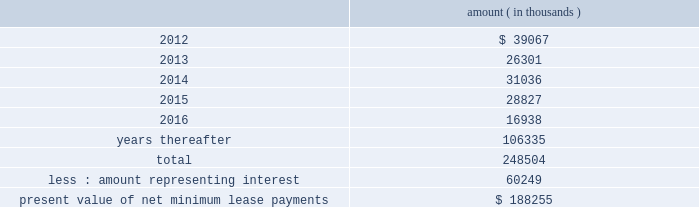Entergy corporation and subsidiaries notes to financial statements sale and leaseback transactions waterford 3 lease obligations in 1989 , in three separate but substantially identical transactions , entergy louisiana sold and leased back undivided interests in waterford 3 for the aggregate sum of $ 353.6 million .
The interests represent approximately 9.3% ( 9.3 % ) of waterford 3 .
The leases expire in 2017 .
Under certain circumstances , entergy louisiana may repurchase the leased interests prior to the end of the term of the leases .
At the end of the lease terms , entergy louisiana has the option to repurchase the leased interests in waterford 3 at fair market value or to renew the leases for either fair market value or , under certain conditions , a fixed rate .
Entergy louisiana issued $ 208.2 million of non-interest bearing first mortgage bonds as collateral for the equity portion of certain amounts payable under the leases .
Upon the occurrence of certain events , entergy louisiana may be obligated to assume the outstanding bonds used to finance the purchase of the interests in the unit and to pay an amount sufficient to withdraw from the lease transaction .
Such events include lease events of default , events of loss , deemed loss events , or certain adverse 201cfinancial events . 201d 201cfinancial events 201d include , among other things , failure by entergy louisiana , following the expiration of any applicable grace or cure period , to maintain ( i ) total equity capital ( including preferred membership interests ) at least equal to 30% ( 30 % ) of adjusted capitalization , or ( ii ) a fixed charge coverage ratio of at least 1.50 computed on a rolling 12 month basis .
As of december 31 , 2011 , entergy louisiana was in compliance with these provisions .
As of december 31 , 2011 , entergy louisiana had future minimum lease payments ( reflecting an overall implicit rate of 7.45% ( 7.45 % ) ) in connection with the waterford 3 sale and leaseback transactions , which are recorded as long-term debt , as follows : amount ( in thousands ) .
Grand gulf lease obligations in 1988 , in two separate but substantially identical transactions , system energy sold and leased back undivided ownership interests in grand gulf for the aggregate sum of $ 500 million .
The interests represent approximately 11.5% ( 11.5 % ) of grand gulf .
The leases expire in 2015 .
Under certain circumstances , system entergy may repurchase the leased interests prior to the end of the term of the leases .
At the end of the lease terms , system energy has the option to repurchase the leased interests in grand gulf at fair market value or to renew the leases for either fair market value or , under certain conditions , a fixed rate .
System energy is required to report the sale-leaseback as a financing transaction in its financial statements .
For financial reporting purposes , system energy expenses the interest portion of the lease obligation and the plant depreciation .
However , operating revenues include the recovery of the lease payments because the transactions are accounted for as a sale and leaseback for ratemaking purposes .
Consistent with a recommendation contained in a .
What portion of the total future minimum lease payments is due within 12 months? 
Computations: (39067 / 248504)
Answer: 0.15721. 